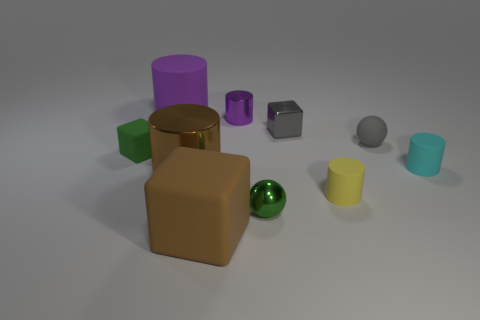There is a small sphere that is in front of the large metal object; what is it made of?
Provide a short and direct response. Metal. How many purple matte objects are the same shape as the tiny yellow rubber object?
Your answer should be very brief. 1. What is the shape of the small green object that is made of the same material as the small purple cylinder?
Offer a very short reply. Sphere. There is a small thing that is behind the tiny cube right of the tiny ball in front of the tiny matte sphere; what shape is it?
Your answer should be very brief. Cylinder. Are there more metallic things than brown things?
Make the answer very short. Yes. What material is the small gray object that is the same shape as the green rubber object?
Provide a short and direct response. Metal. Do the yellow cylinder and the cyan thing have the same material?
Ensure brevity in your answer.  Yes. Is the number of tiny cyan things that are on the right side of the large brown cube greater than the number of tiny green metallic spheres?
Keep it short and to the point. No. There is a ball that is to the right of the tiny ball in front of the tiny thing that is left of the tiny purple metal thing; what is it made of?
Your response must be concise. Rubber. What number of objects are big brown shiny objects or objects in front of the tiny cyan thing?
Make the answer very short. 4. 